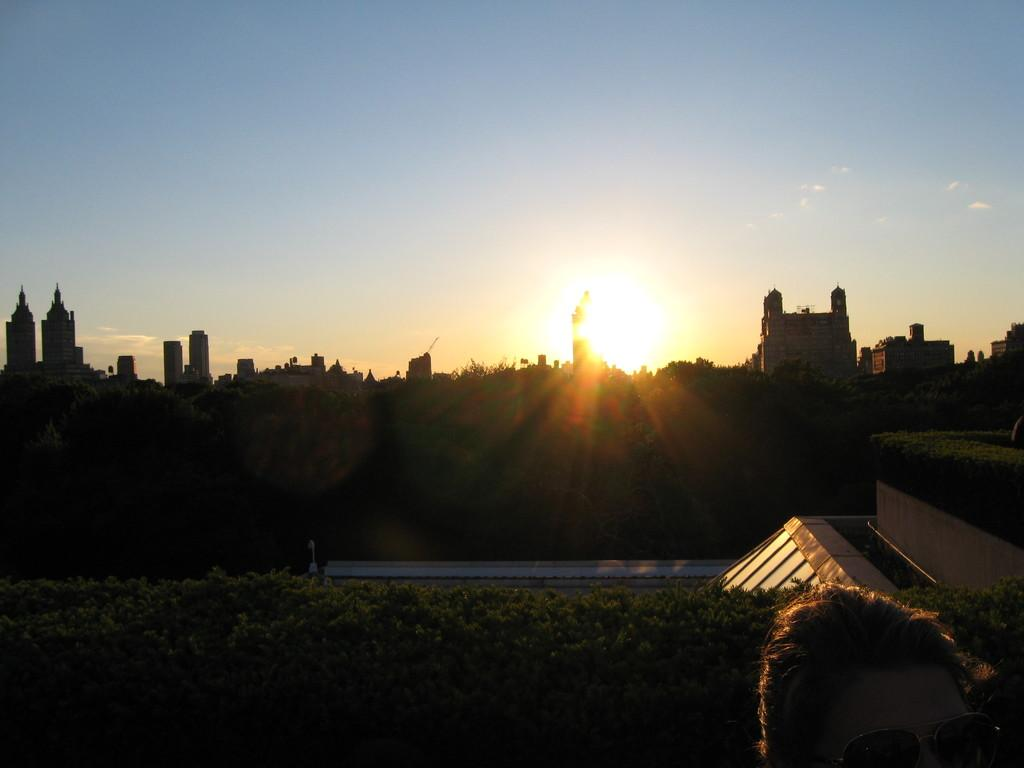What type of natural elements can be seen in the image? There are trees in the image. Can you identify any human presence in the image? Yes, a person's head is visible in the image. What type of man-made structures are present in the image? There are buildings in the image. What can be seen in the background of the image? The sky is visible in the background of the image. What celestial body is visible in the sky? The sun is visible in the sky. What language is the person speaking in the image? There is no indication of speech or language in the image. How does the thunder sound in the image? There is no thunder present in the image. 